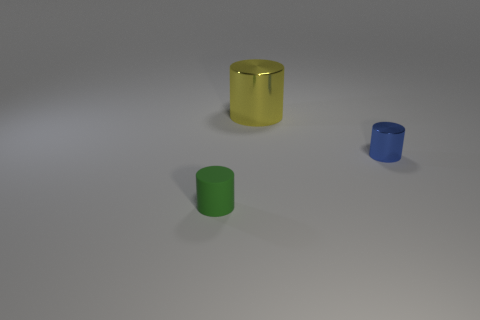Subtract all big yellow shiny cylinders. How many cylinders are left? 2 Add 2 tiny matte things. How many objects exist? 5 Subtract 1 cylinders. How many cylinders are left? 2 Subtract all green cylinders. How many cylinders are left? 2 Subtract 0 brown spheres. How many objects are left? 3 Subtract all brown cylinders. Subtract all yellow spheres. How many cylinders are left? 3 Subtract all small matte objects. Subtract all large metallic cylinders. How many objects are left? 1 Add 1 tiny things. How many tiny things are left? 3 Add 2 tiny brown shiny balls. How many tiny brown shiny balls exist? 2 